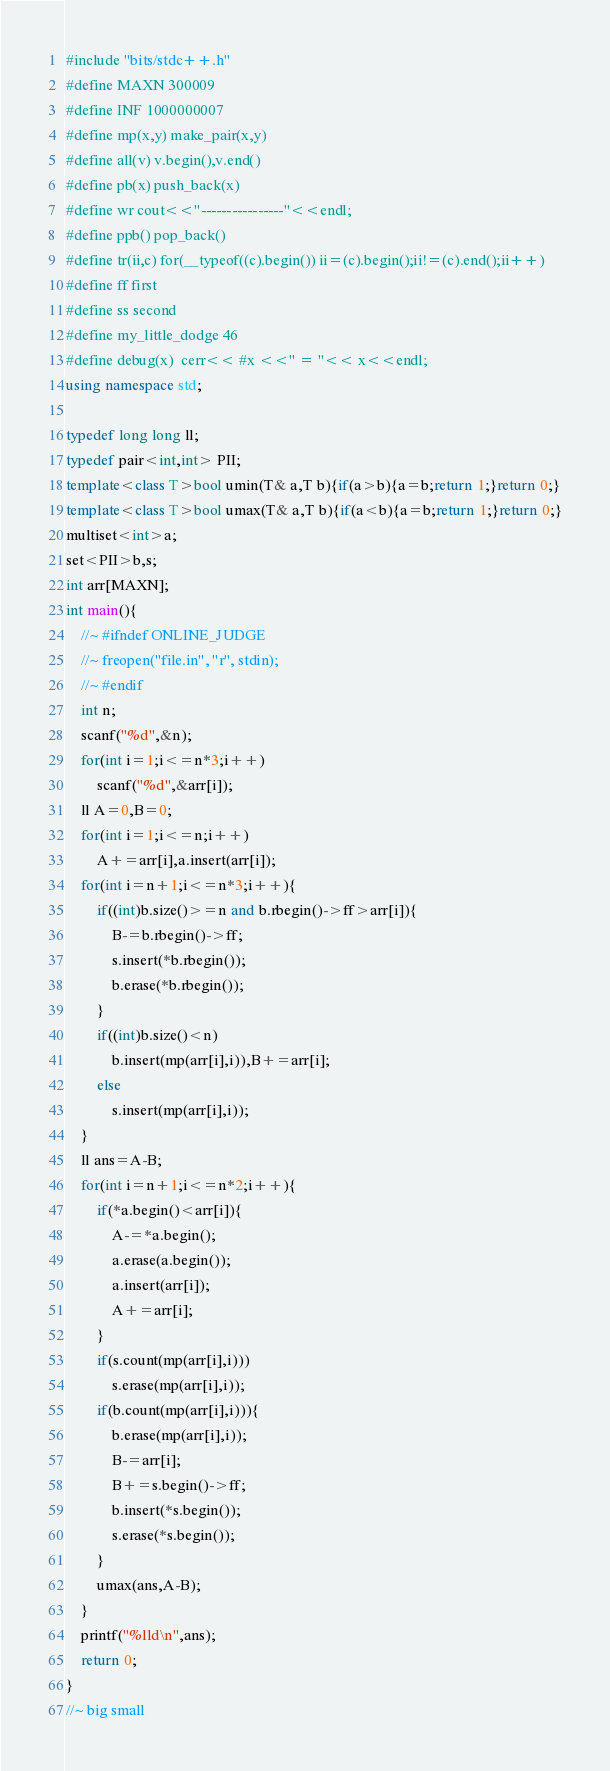<code> <loc_0><loc_0><loc_500><loc_500><_C++_>#include "bits/stdc++.h"
#define MAXN 300009
#define INF 1000000007
#define mp(x,y) make_pair(x,y)
#define all(v) v.begin(),v.end()
#define pb(x) push_back(x)
#define wr cout<<"----------------"<<endl;
#define ppb() pop_back()
#define tr(ii,c) for(__typeof((c).begin()) ii=(c).begin();ii!=(c).end();ii++)
#define ff first
#define ss second
#define my_little_dodge 46
#define debug(x)  cerr<< #x <<" = "<< x<<endl;
using namespace std;

typedef long long ll;
typedef pair<int,int> PII;
template<class T>bool umin(T& a,T b){if(a>b){a=b;return 1;}return 0;}
template<class T>bool umax(T& a,T b){if(a<b){a=b;return 1;}return 0;}
multiset<int>a;
set<PII>b,s;
int arr[MAXN];
int main(){
	//~ #ifndef ONLINE_JUDGE
    //~ freopen("file.in", "r", stdin);
	//~ #endif	
	int n;
	scanf("%d",&n);
	for(int i=1;i<=n*3;i++)
		scanf("%d",&arr[i]);
	ll A=0,B=0;
	for(int i=1;i<=n;i++)
		A+=arr[i],a.insert(arr[i]);
	for(int i=n+1;i<=n*3;i++){
		if((int)b.size()>=n and b.rbegin()->ff>arr[i]){
			B-=b.rbegin()->ff;
			s.insert(*b.rbegin());
			b.erase(*b.rbegin());
		}
		if((int)b.size()<n)
			b.insert(mp(arr[i],i)),B+=arr[i];
		else
			s.insert(mp(arr[i],i));
	}	
	ll ans=A-B;
	for(int i=n+1;i<=n*2;i++){	
		if(*a.begin()<arr[i]){
			A-=*a.begin();
			a.erase(a.begin());
			a.insert(arr[i]);
			A+=arr[i];
		}
		if(s.count(mp(arr[i],i)))
			s.erase(mp(arr[i],i));
		if(b.count(mp(arr[i],i))){
			b.erase(mp(arr[i],i));
			B-=arr[i];
			B+=s.begin()->ff;
			b.insert(*s.begin());
			s.erase(*s.begin());
		}
		umax(ans,A-B);
	}
	printf("%lld\n",ans);
	return 0;
}
//~ big small
</code> 